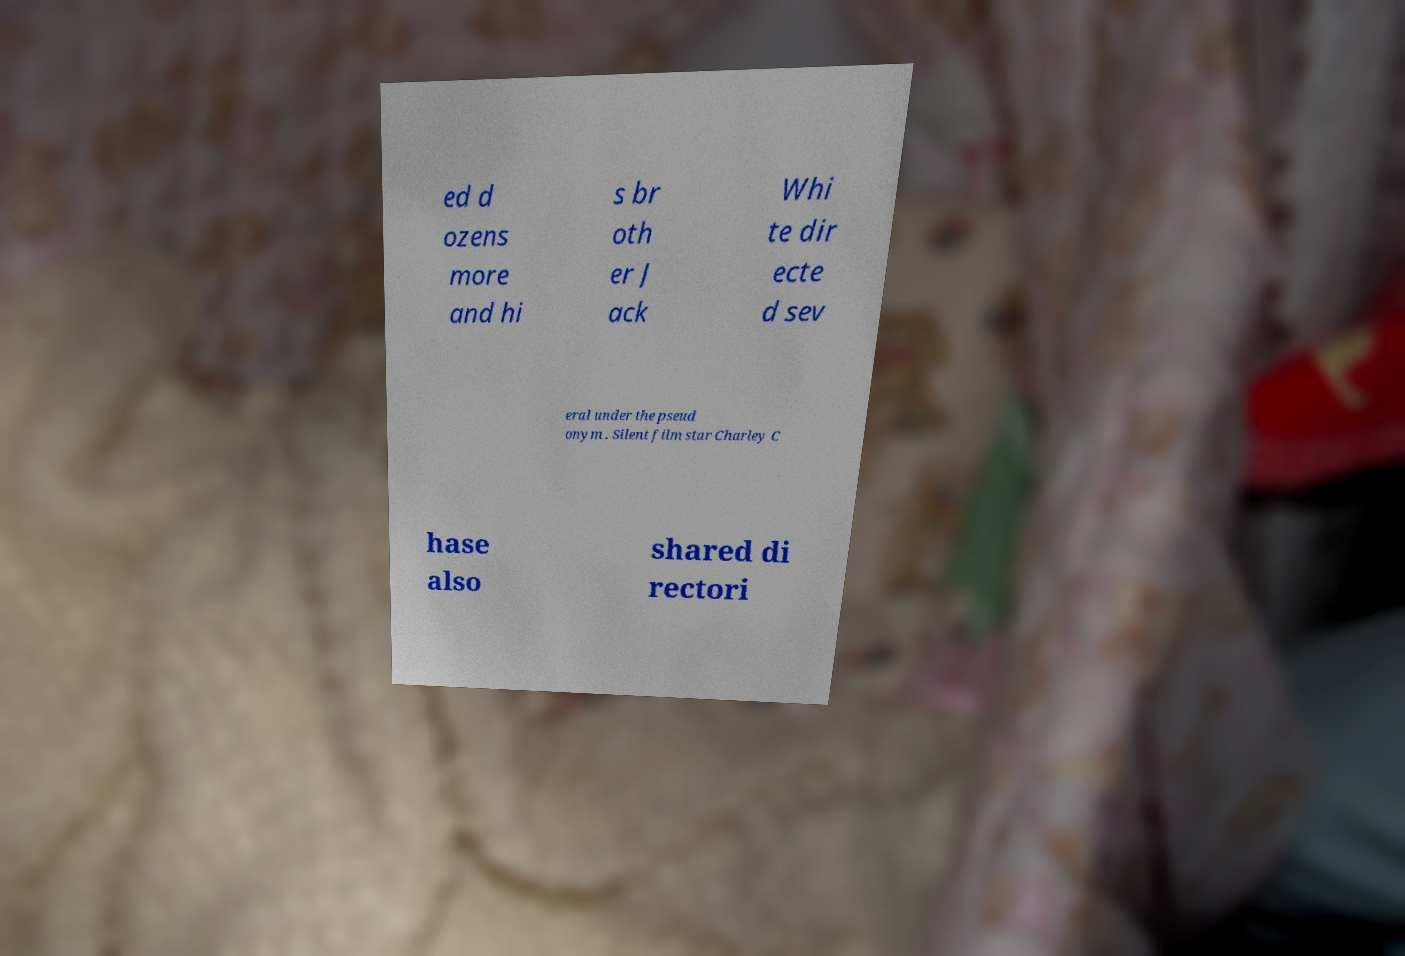Please identify and transcribe the text found in this image. ed d ozens more and hi s br oth er J ack Whi te dir ecte d sev eral under the pseud onym . Silent film star Charley C hase also shared di rectori 